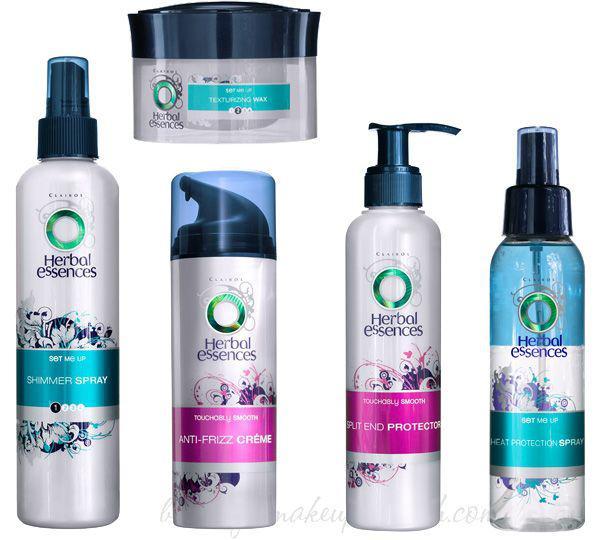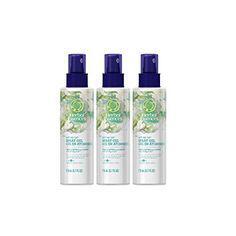The first image is the image on the left, the second image is the image on the right. Analyze the images presented: Is the assertion "There are a total of two beauty product containers." valid? Answer yes or no. No. The first image is the image on the left, the second image is the image on the right. Examine the images to the left and right. Is the description "One image shows a single bottle with its applicator top next to it." accurate? Answer yes or no. No. 